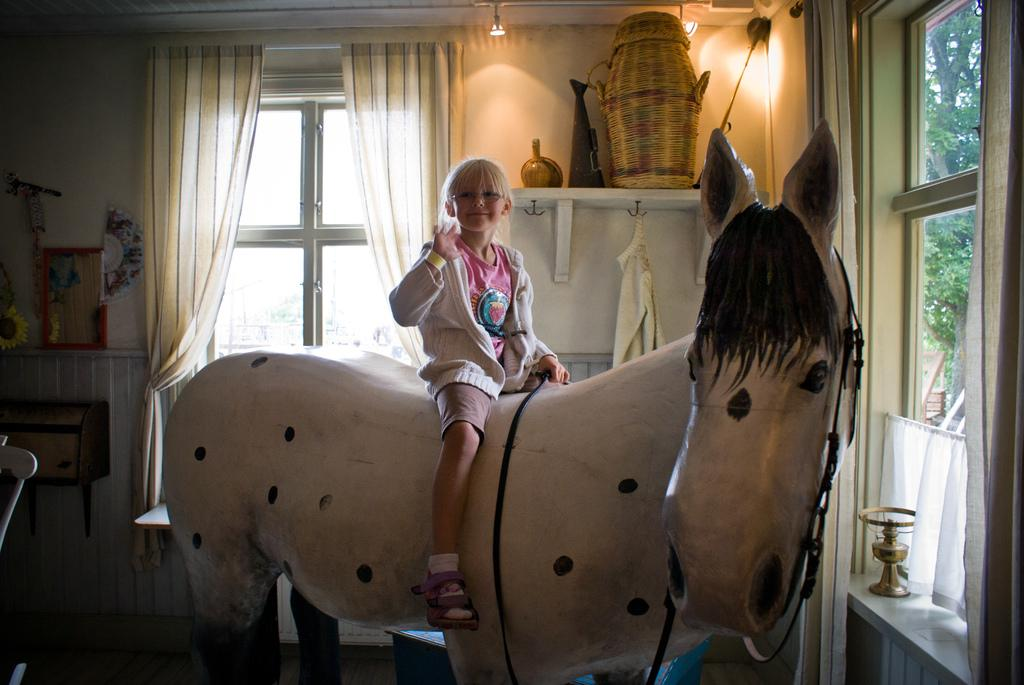What is the main subject of the image? There is a child in the image. What is the child sitting on? The child is sitting on a horse doll. What can be seen behind the child? There is a window behind the child, and curtains are associated with the window. What is visible in front of the child? There is a window in front of the child. What can be seen outside the window in front of the child? Greenery is visible outside the window in front of the child. What type of secretary can be seen working in the image? There is no secretary present in the image; it features a child sitting on a horse doll. How many lizards are visible on the horse doll in the image? There are no lizards visible on the horse doll in the image. 